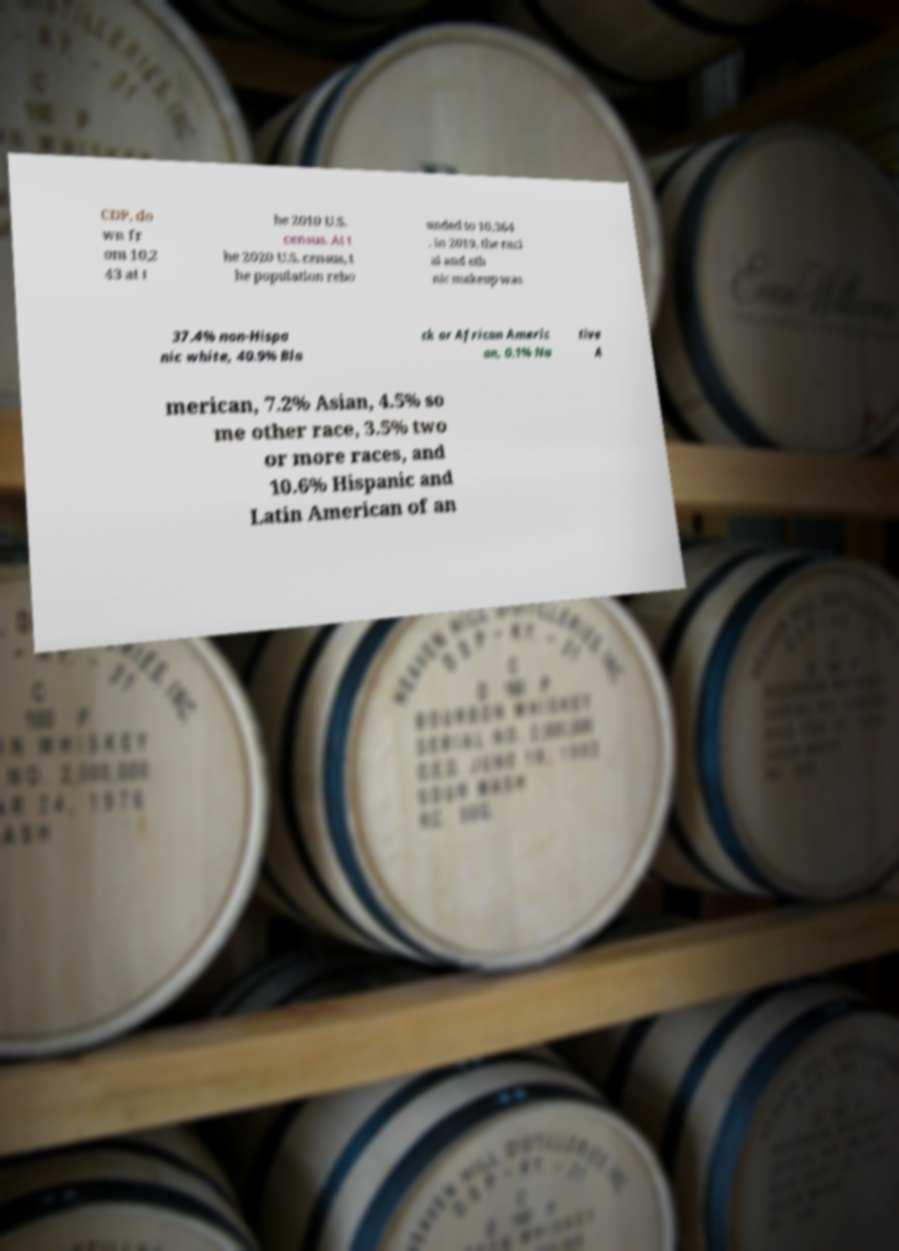Please identify and transcribe the text found in this image. CDP, do wn fr om 10,2 43 at t he 2010 U.S. census. At t he 2020 U.S. census, t he population rebo unded to 10,364 . In 2019, the raci al and eth nic makeup was 37.4% non-Hispa nic white, 40.9% Bla ck or African Americ an, 0.1% Na tive A merican, 7.2% Asian, 4.5% so me other race, 3.5% two or more races, and 10.6% Hispanic and Latin American of an 